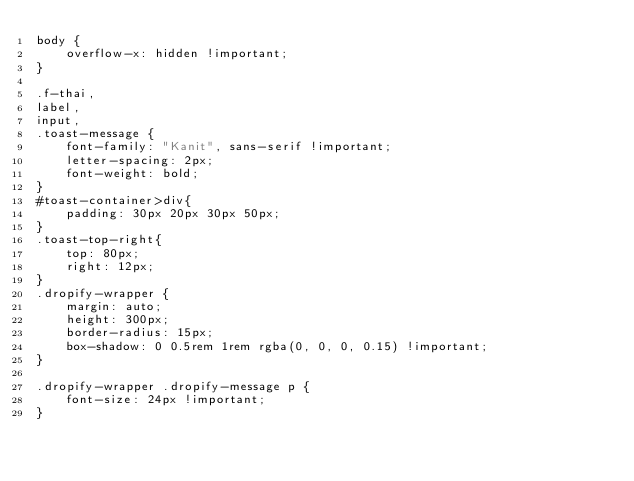<code> <loc_0><loc_0><loc_500><loc_500><_CSS_>body {
    overflow-x: hidden !important;
}

.f-thai,
label,
input,
.toast-message {
    font-family: "Kanit", sans-serif !important;
    letter-spacing: 2px;
    font-weight: bold;
}
#toast-container>div{
    padding: 30px 20px 30px 50px;
}
.toast-top-right{
    top: 80px;
    right: 12px;
}
.dropify-wrapper {
    margin: auto;
    height: 300px;
    border-radius: 15px;
    box-shadow: 0 0.5rem 1rem rgba(0, 0, 0, 0.15) !important;
}

.dropify-wrapper .dropify-message p {
    font-size: 24px !important;
}
</code> 